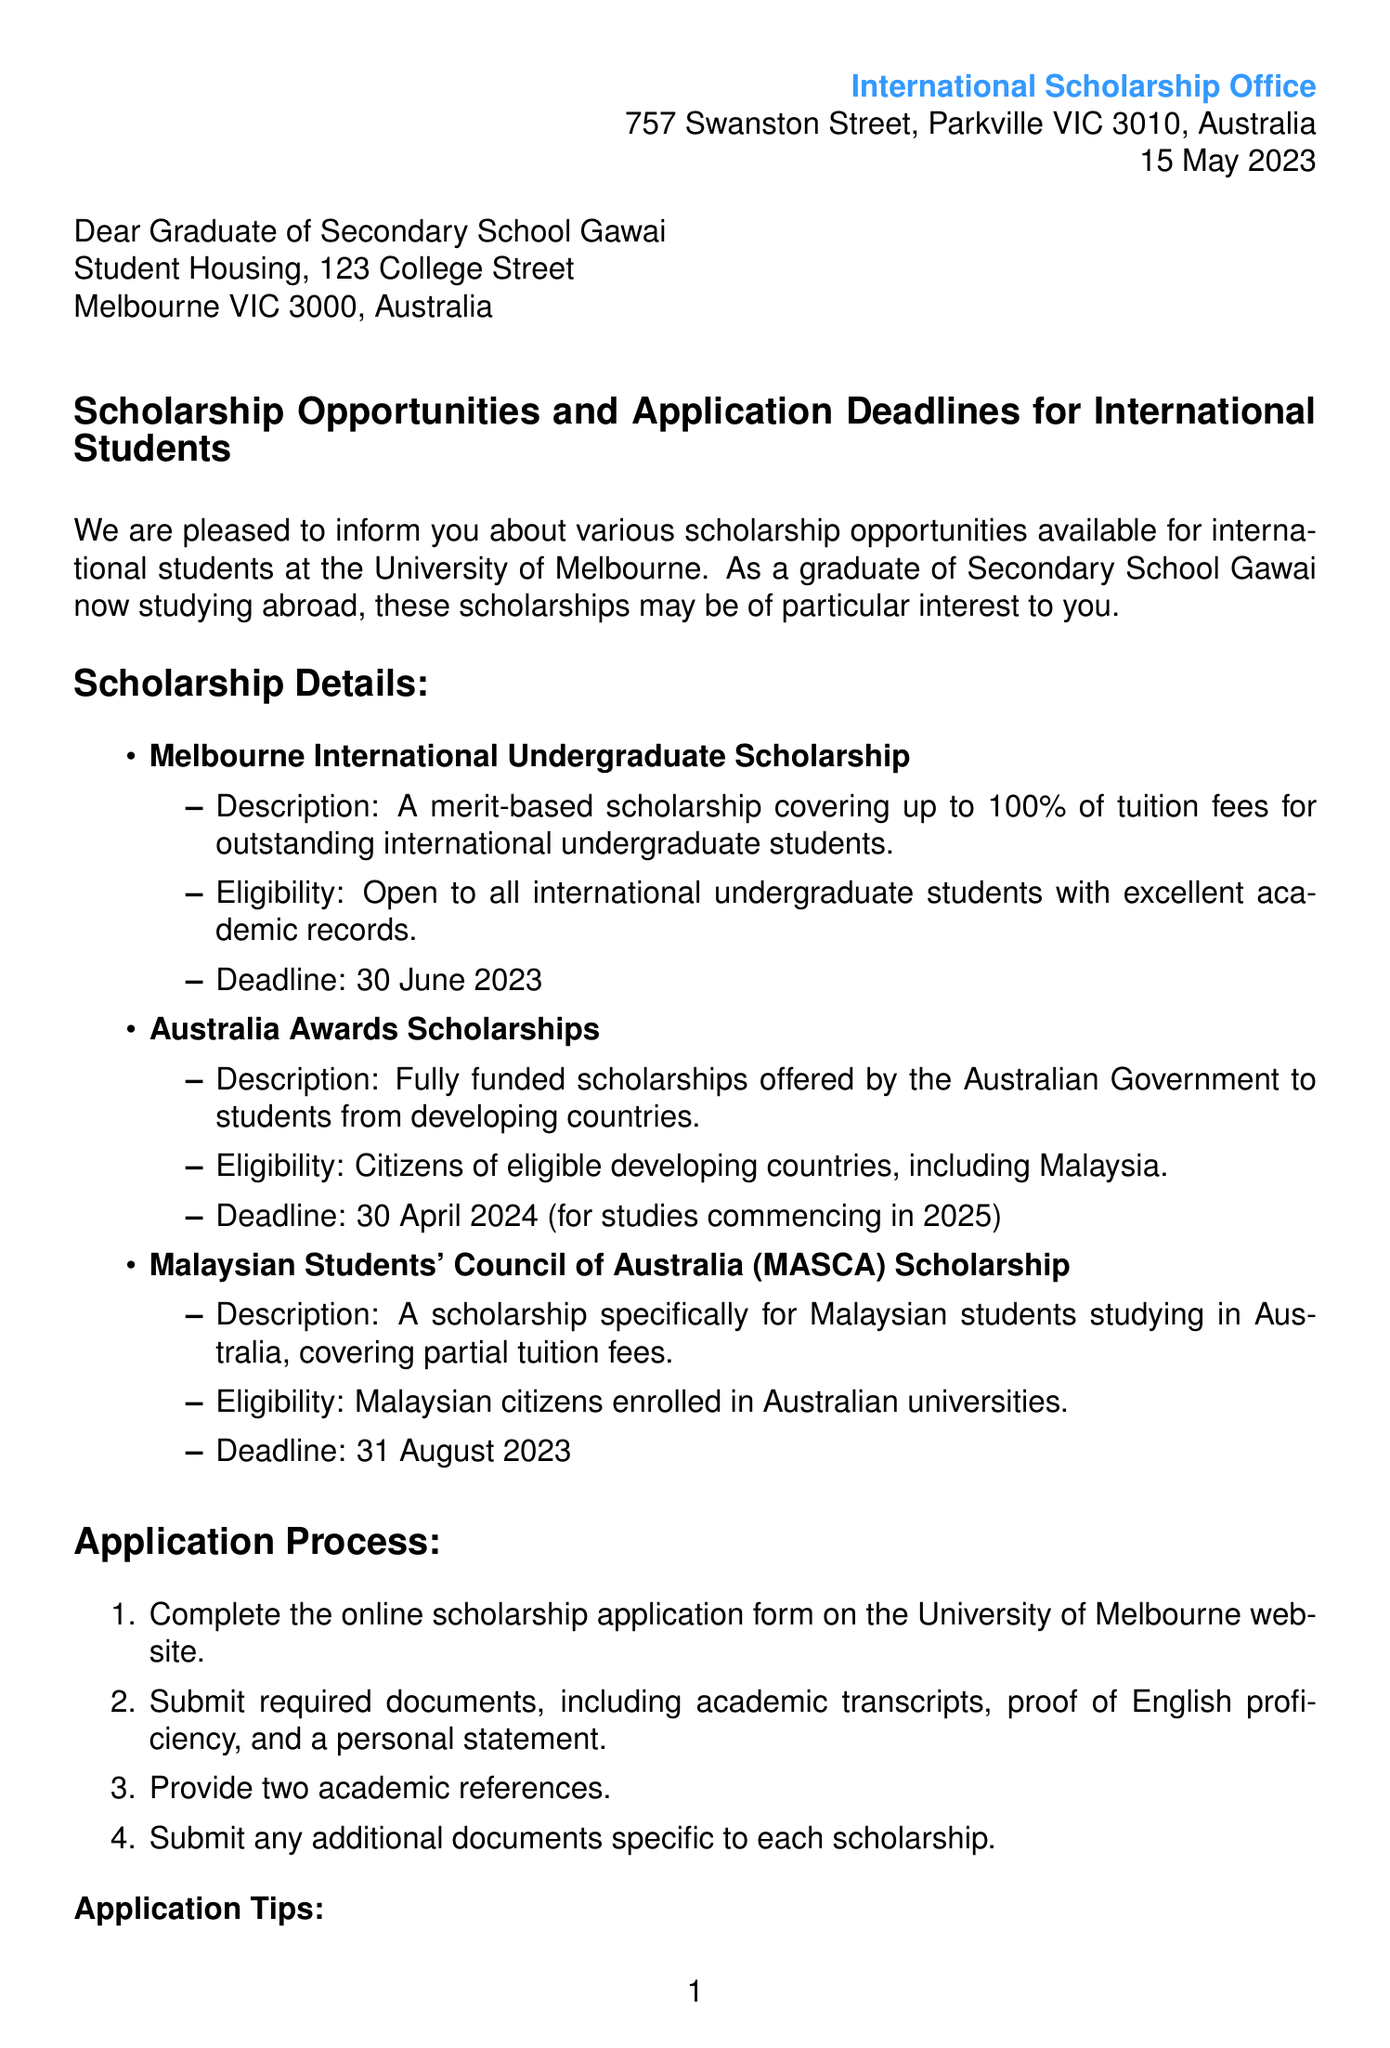What is the name of the office sending the letter? The letter is from the International Scholarship Office at the University of Melbourne.
Answer: International Scholarship Office What is the address of the University of Melbourne? The address of the university is provided at the beginning of the letter.
Answer: 757 Swanston Street, Parkville VIC 3010, Australia When is the deadline for the Melbourne International Undergraduate Scholarship? The specific deadline for this scholarship is mentioned in the scholarship details section.
Answer: 30 June 2023 Which scholarship is specifically for Malaysian students? The scholarship details include specific scholarships tailored for Malaysian students among the listed options.
Answer: Malaysian Students' Council of Australia (MASCA) Scholarship What should be submitted along with the application form? The application process outlines required documents to submit, indicating their importance for the application.
Answer: Academic transcripts, proof of English proficiency, and a personal statement Who should be contacted for support services? The support services section mentions an office for assistance if needed.
Answer: International Student Support Office What is encouraged in the conclusion of the letter? The conclusion includes an encouragement for the recipient regarding scholarship applications.
Answer: Take advantage of these opportunities What is the email address provided for inquiries? The support services section lists contact information, including an email address for scholarships.
Answer: int-scholarships@unimelb.edu.au From whom is the letter signed? The closing of the letter indicates the person who is signing it, showing their title and affiliation.
Answer: Dr. Sarah Thompson 